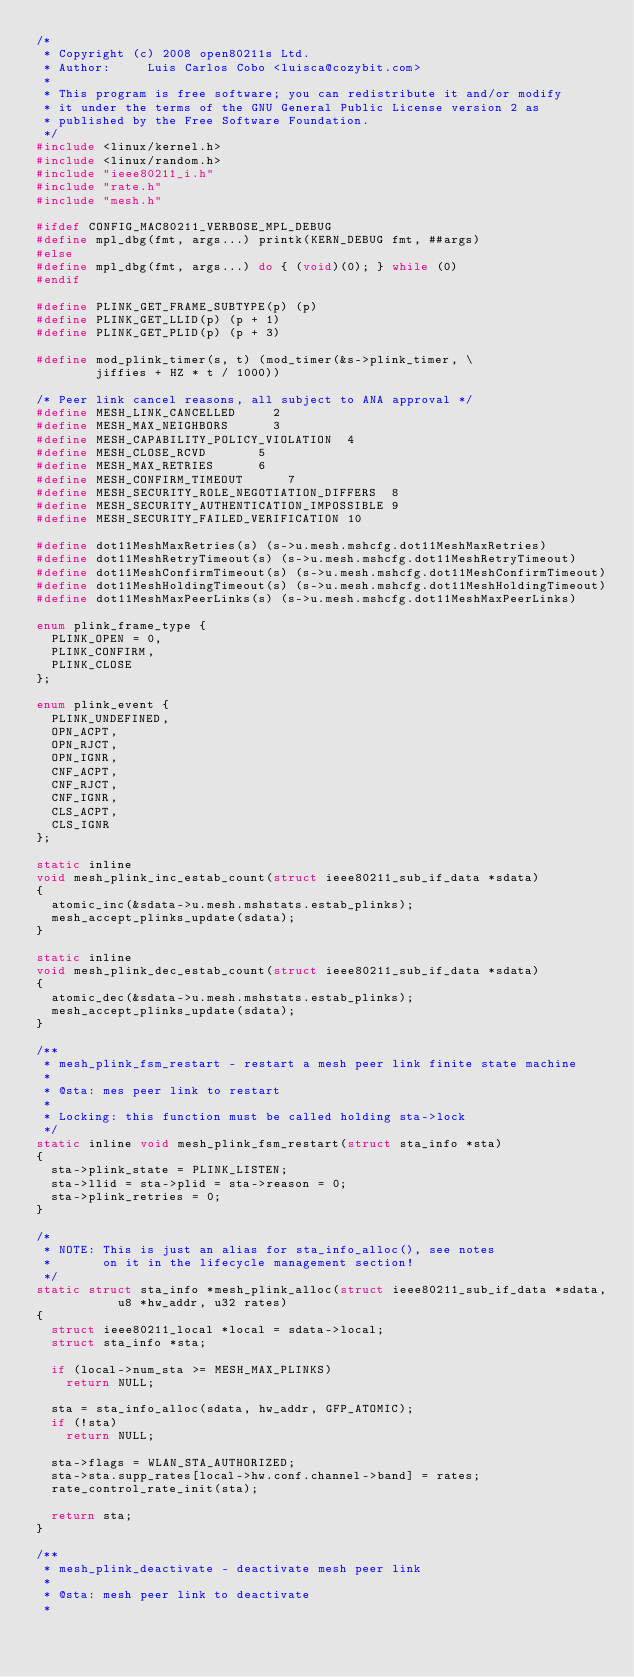<code> <loc_0><loc_0><loc_500><loc_500><_C_>/*
 * Copyright (c) 2008 open80211s Ltd.
 * Author:     Luis Carlos Cobo <luisca@cozybit.com>
 *
 * This program is free software; you can redistribute it and/or modify
 * it under the terms of the GNU General Public License version 2 as
 * published by the Free Software Foundation.
 */
#include <linux/kernel.h>
#include <linux/random.h>
#include "ieee80211_i.h"
#include "rate.h"
#include "mesh.h"

#ifdef CONFIG_MAC80211_VERBOSE_MPL_DEBUG
#define mpl_dbg(fmt, args...)	printk(KERN_DEBUG fmt, ##args)
#else
#define mpl_dbg(fmt, args...)	do { (void)(0); } while (0)
#endif

#define PLINK_GET_FRAME_SUBTYPE(p) (p)
#define PLINK_GET_LLID(p) (p + 1)
#define PLINK_GET_PLID(p) (p + 3)

#define mod_plink_timer(s, t) (mod_timer(&s->plink_timer, \
				jiffies + HZ * t / 1000))

/* Peer link cancel reasons, all subject to ANA approval */
#define MESH_LINK_CANCELLED			2
#define MESH_MAX_NEIGHBORS			3
#define MESH_CAPABILITY_POLICY_VIOLATION	4
#define MESH_CLOSE_RCVD				5
#define MESH_MAX_RETRIES			6
#define MESH_CONFIRM_TIMEOUT			7
#define MESH_SECURITY_ROLE_NEGOTIATION_DIFFERS	8
#define MESH_SECURITY_AUTHENTICATION_IMPOSSIBLE	9
#define MESH_SECURITY_FAILED_VERIFICATION	10

#define dot11MeshMaxRetries(s) (s->u.mesh.mshcfg.dot11MeshMaxRetries)
#define dot11MeshRetryTimeout(s) (s->u.mesh.mshcfg.dot11MeshRetryTimeout)
#define dot11MeshConfirmTimeout(s) (s->u.mesh.mshcfg.dot11MeshConfirmTimeout)
#define dot11MeshHoldingTimeout(s) (s->u.mesh.mshcfg.dot11MeshHoldingTimeout)
#define dot11MeshMaxPeerLinks(s) (s->u.mesh.mshcfg.dot11MeshMaxPeerLinks)

enum plink_frame_type {
	PLINK_OPEN = 0,
	PLINK_CONFIRM,
	PLINK_CLOSE
};

enum plink_event {
	PLINK_UNDEFINED,
	OPN_ACPT,
	OPN_RJCT,
	OPN_IGNR,
	CNF_ACPT,
	CNF_RJCT,
	CNF_IGNR,
	CLS_ACPT,
	CLS_IGNR
};

static inline
void mesh_plink_inc_estab_count(struct ieee80211_sub_if_data *sdata)
{
	atomic_inc(&sdata->u.mesh.mshstats.estab_plinks);
	mesh_accept_plinks_update(sdata);
}

static inline
void mesh_plink_dec_estab_count(struct ieee80211_sub_if_data *sdata)
{
	atomic_dec(&sdata->u.mesh.mshstats.estab_plinks);
	mesh_accept_plinks_update(sdata);
}

/**
 * mesh_plink_fsm_restart - restart a mesh peer link finite state machine
 *
 * @sta: mes peer link to restart
 *
 * Locking: this function must be called holding sta->lock
 */
static inline void mesh_plink_fsm_restart(struct sta_info *sta)
{
	sta->plink_state = PLINK_LISTEN;
	sta->llid = sta->plid = sta->reason = 0;
	sta->plink_retries = 0;
}

/*
 * NOTE: This is just an alias for sta_info_alloc(), see notes
 *       on it in the lifecycle management section!
 */
static struct sta_info *mesh_plink_alloc(struct ieee80211_sub_if_data *sdata,
					 u8 *hw_addr, u32 rates)
{
	struct ieee80211_local *local = sdata->local;
	struct sta_info *sta;

	if (local->num_sta >= MESH_MAX_PLINKS)
		return NULL;

	sta = sta_info_alloc(sdata, hw_addr, GFP_ATOMIC);
	if (!sta)
		return NULL;

	sta->flags = WLAN_STA_AUTHORIZED;
	sta->sta.supp_rates[local->hw.conf.channel->band] = rates;
	rate_control_rate_init(sta);

	return sta;
}

/**
 * mesh_plink_deactivate - deactivate mesh peer link
 *
 * @sta: mesh peer link to deactivate
 *</code> 